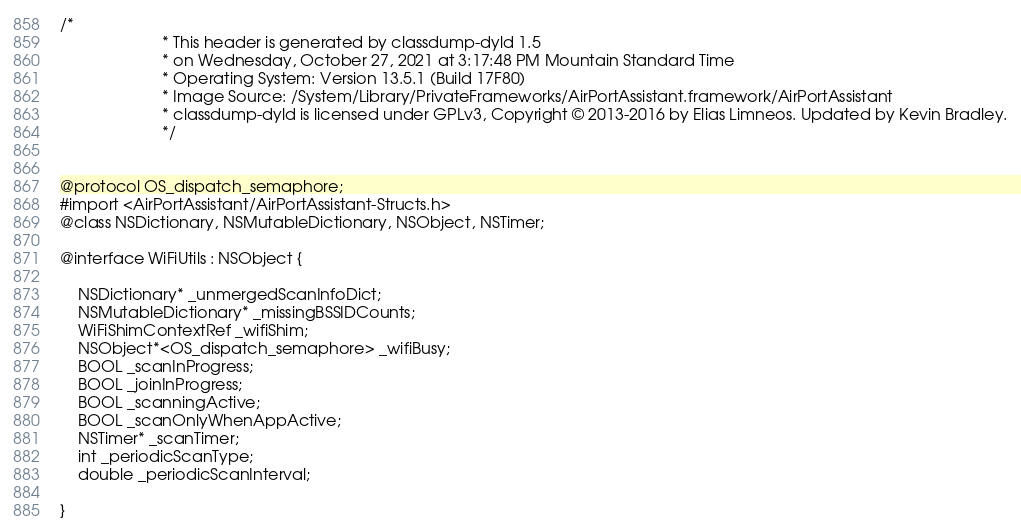Convert code to text. <code><loc_0><loc_0><loc_500><loc_500><_C_>/*
                       * This header is generated by classdump-dyld 1.5
                       * on Wednesday, October 27, 2021 at 3:17:48 PM Mountain Standard Time
                       * Operating System: Version 13.5.1 (Build 17F80)
                       * Image Source: /System/Library/PrivateFrameworks/AirPortAssistant.framework/AirPortAssistant
                       * classdump-dyld is licensed under GPLv3, Copyright © 2013-2016 by Elias Limneos. Updated by Kevin Bradley.
                       */


@protocol OS_dispatch_semaphore;
#import <AirPortAssistant/AirPortAssistant-Structs.h>
@class NSDictionary, NSMutableDictionary, NSObject, NSTimer;

@interface WiFiUtils : NSObject {

	NSDictionary* _unmergedScanInfoDict;
	NSMutableDictionary* _missingBSSIDCounts;
	WiFiShimContextRef _wifiShim;
	NSObject*<OS_dispatch_semaphore> _wifiBusy;
	BOOL _scanInProgress;
	BOOL _joinInProgress;
	BOOL _scanningActive;
	BOOL _scanOnlyWhenAppActive;
	NSTimer* _scanTimer;
	int _periodicScanType;
	double _periodicScanInterval;

}
</code> 